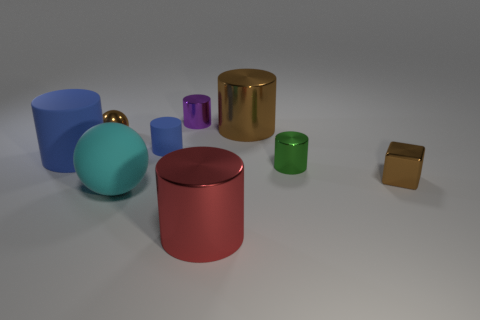Subtract all big brown cylinders. How many cylinders are left? 5 Subtract all red cubes. Subtract all red spheres. How many cubes are left? 1 Subtract all purple spheres. How many green blocks are left? 0 Subtract all gray shiny cubes. Subtract all rubber things. How many objects are left? 6 Add 6 brown shiny things. How many brown shiny things are left? 9 Add 7 tiny purple shiny cylinders. How many tiny purple shiny cylinders exist? 8 Subtract all red cylinders. How many cylinders are left? 5 Subtract 1 green cylinders. How many objects are left? 8 Subtract all cylinders. How many objects are left? 3 